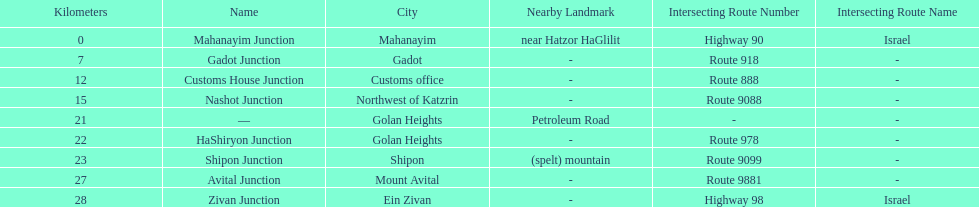Is nashot junction closer to shipon junction or avital junction? Shipon Junction. 